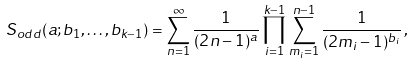Convert formula to latex. <formula><loc_0><loc_0><loc_500><loc_500>S _ { o d d } ( a ; b _ { 1 } , \dots , b _ { k - 1 } ) = \sum _ { n = 1 } ^ { \infty } \frac { 1 } { ( 2 n - 1 ) ^ { a } } \prod _ { i = 1 } ^ { k - 1 } \sum _ { m _ { i } = 1 } ^ { n - 1 } \frac { 1 } { ( 2 m _ { i } - 1 ) ^ { b _ { i } } } \, ,</formula> 